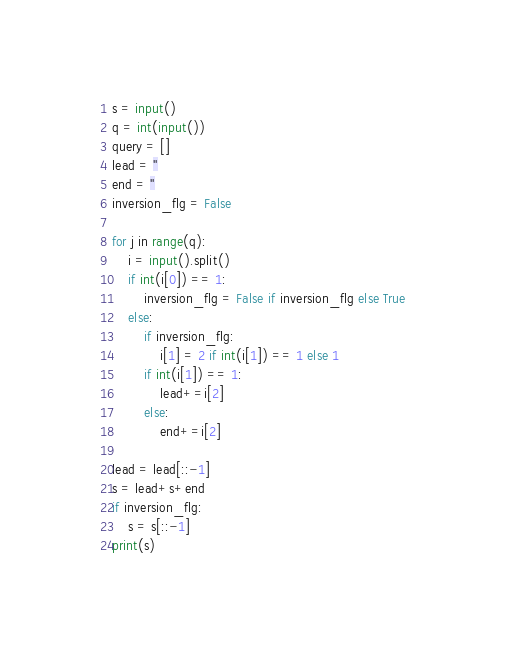Convert code to text. <code><loc_0><loc_0><loc_500><loc_500><_Python_>s = input()
q = int(input())
query = []
lead = ''
end = ''
inversion_flg = False

for j in range(q):
    i = input().split()
    if int(i[0]) == 1:
        inversion_flg = False if inversion_flg else True
    else:
        if inversion_flg:
            i[1] = 2 if int(i[1]) == 1 else 1
        if int(i[1]) == 1:
            lead+=i[2]
        else:
            end+=i[2]

lead = lead[::-1]
s = lead+s+end
if inversion_flg:
    s = s[::-1]
print(s)</code> 